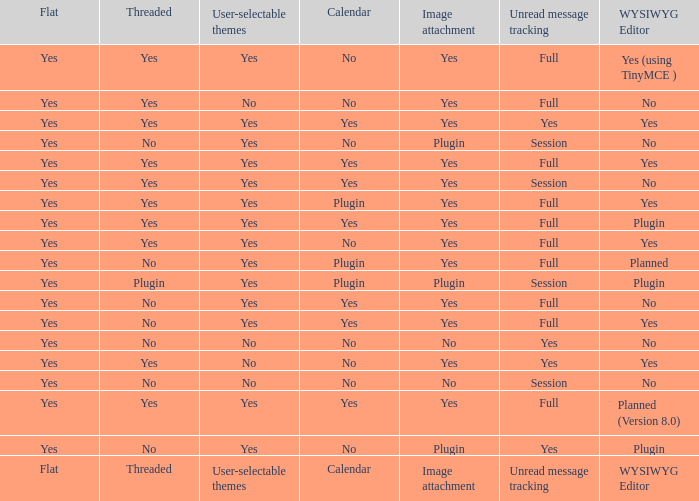Which Calendar has WYSIWYG Editor of yes and an Unread message tracking of yes? Yes, No. 